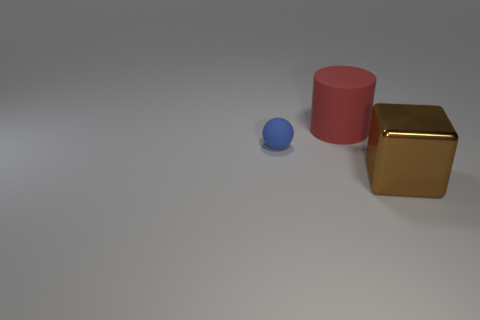Subtract all cylinders. How many objects are left? 2 Add 2 small blue objects. How many objects exist? 5 Add 3 rubber balls. How many rubber balls are left? 4 Add 1 brown cubes. How many brown cubes exist? 2 Subtract 0 green cylinders. How many objects are left? 3 Subtract all red things. Subtract all tiny blue rubber spheres. How many objects are left? 1 